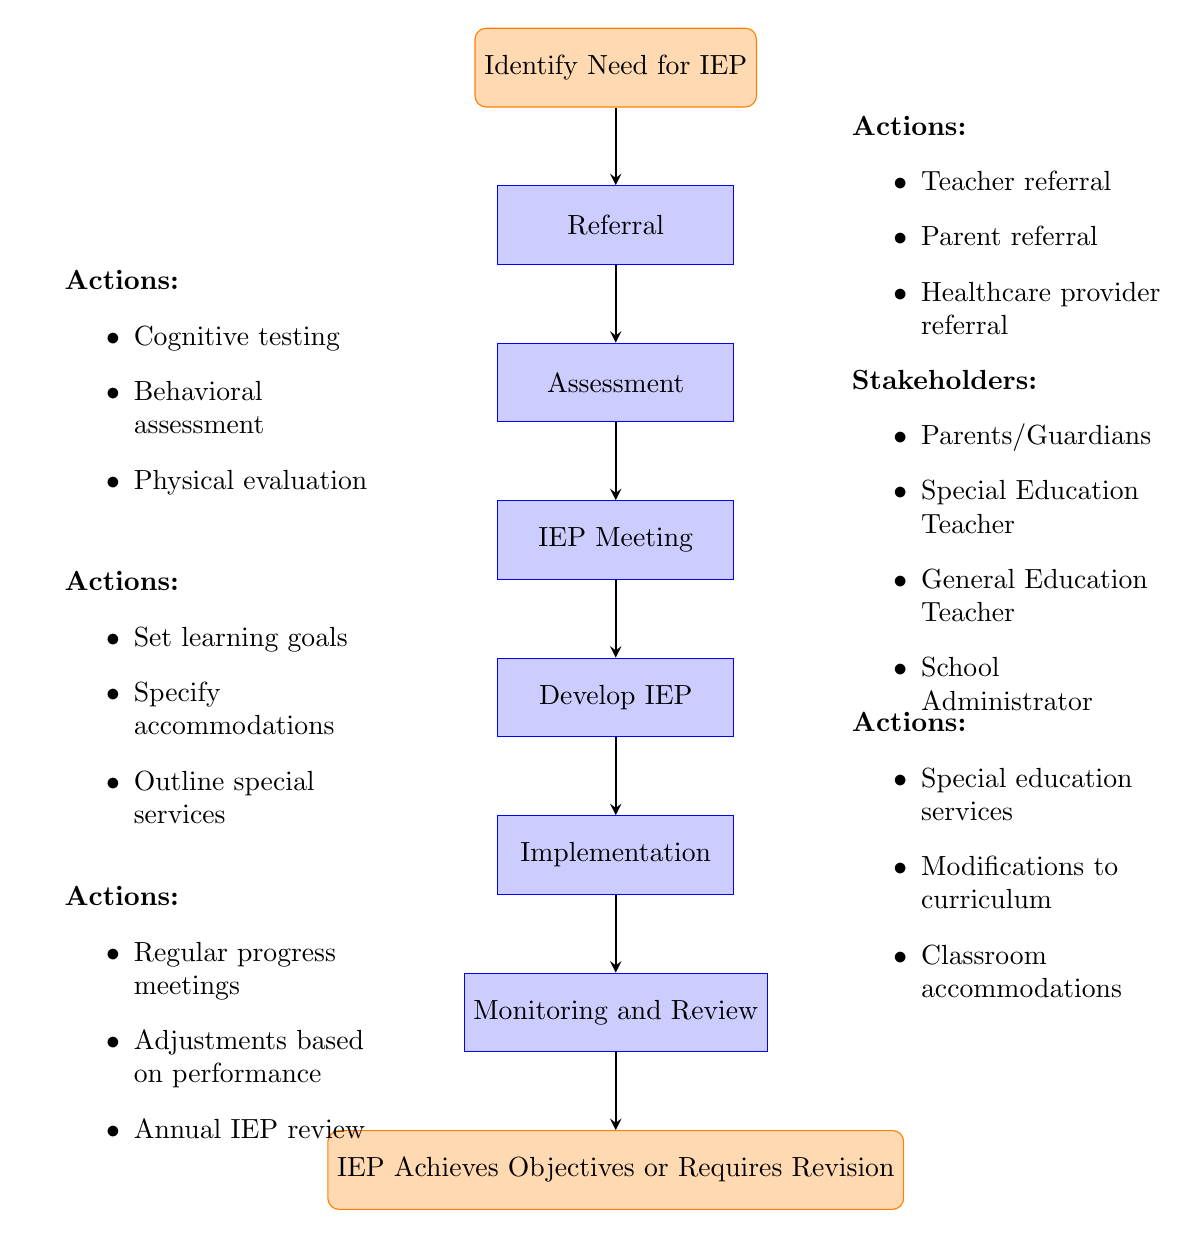What is the first step in the IEP process? The first step in the IEP process, as shown in the diagram, is "Identify Need for IEP." This is the starting point from which all other steps follow.
Answer: Identify Need for IEP How many actions are listed under the "Referral" step? There are three actions listed under the "Referral" step: teacher referral, parent referral, and healthcare provider referral. To find the number, we simply count these actions.
Answer: 3 What stakeholders are involved in the "IEP Meeting"? The stakeholders involved in the "IEP Meeting" are parents/guardians, special education teacher, general education teacher, and school administrator. These are specifically mentioned next to the meeting node.
Answer: Parents/Guardians, Special Education Teacher, General Education Teacher, School Administrator What actions are specified in the "Develop IEP" step? The actions specified in the "Develop IEP" step include setting learning goals, specifying accommodations, and outlining special services. This information is presented next to the "Develop IEP" node in the flowchart.
Answer: Set learning goals, Specify accommodations, Outline special services Which step comes after "Implementation"? After the "Implementation" step, the next step is "Monitoring and Review." The arrows in the flowchart directly connect these two nodes, showing their sequence.
Answer: Monitoring and Review What is the final outcome indicated in the flowchart? The final outcome indicated in the flowchart is "IEP Achieves Objectives or Requires Revision." This is the terminating node that presents the end result of the IEP process.
Answer: IEP Achieves Objectives or Requires Revision What types of assessments are involved in the "Assessment" step? The assessments involved in the "Assessment" step are cognitive testing, behavioral assessment, and physical evaluation. These types are listed next to the assessment node in the diagram.
Answer: Cognitive testing, Behavioral assessment, Physical evaluation How many total steps are there in the IEP process? There are six total steps in the IEP process, starting from "Identify Need for IEP" and ending with "Monitoring and Review." Counting all nodes before the final outcome gives us this total.
Answer: 6 